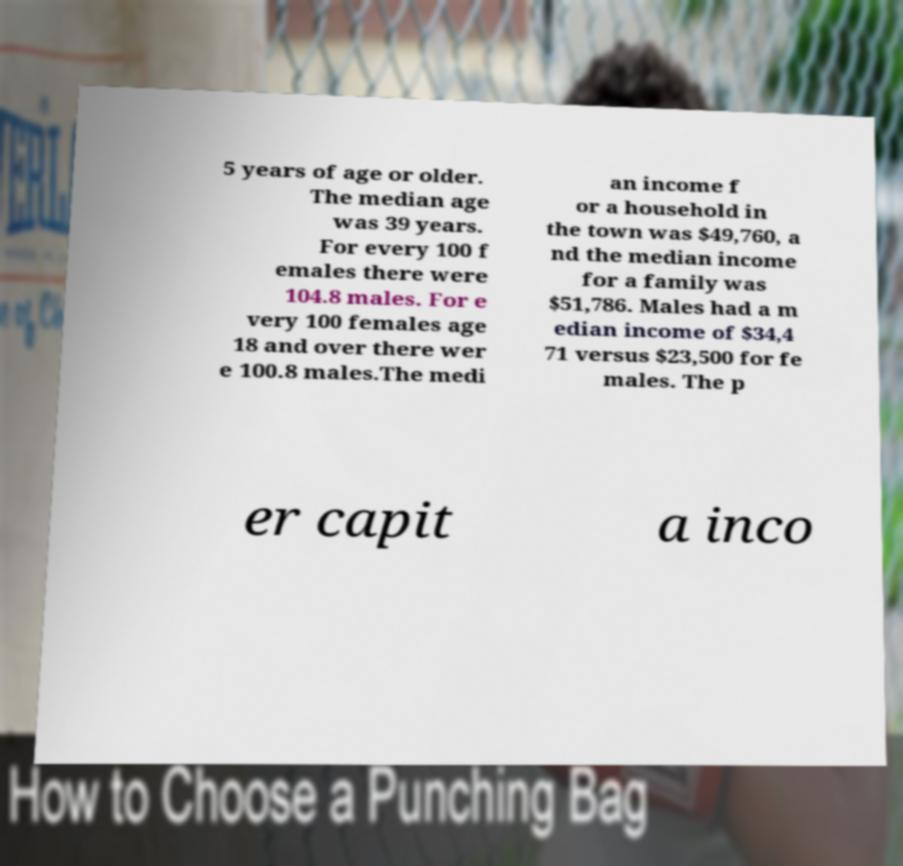Can you read and provide the text displayed in the image?This photo seems to have some interesting text. Can you extract and type it out for me? 5 years of age or older. The median age was 39 years. For every 100 f emales there were 104.8 males. For e very 100 females age 18 and over there wer e 100.8 males.The medi an income f or a household in the town was $49,760, a nd the median income for a family was $51,786. Males had a m edian income of $34,4 71 versus $23,500 for fe males. The p er capit a inco 